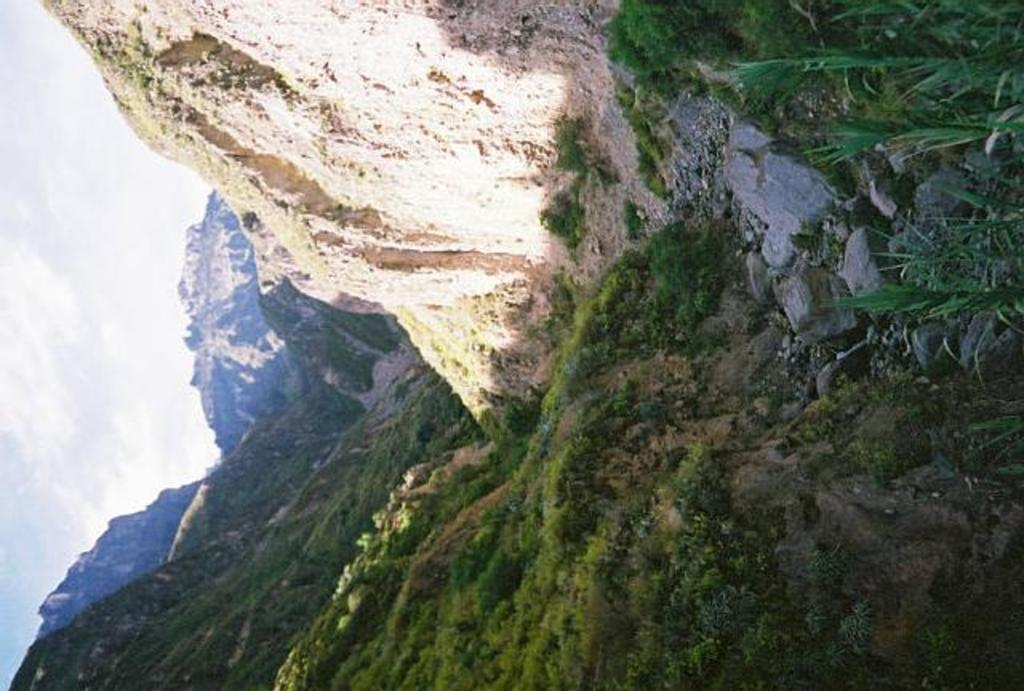What types of natural elements can be seen on the right side of the image? A: There are stones, grass, and plants on the right side of the image. What is located in the middle of the image? There are mountains and grass in the middle of the image. What is visible on the left side of the image? There are mountains on the left side of the image. How would you describe the sky in the image? The sky is cloudy. Reasoning: Let' Let's think step by step in order to produce the conversation. We start by identifying the main subjects and objects in the image based on the provided facts. We then formulate questions that focus on the location and characteristics of these subjects and objects, ensuring that each question can be answered definitively with the information given. We avoid yes/no questions and ensure that the language is simple and clear. Absurd Question/Answer: Can you see the thumb of the person who took the photo in the image? There is no thumb visible in the image, as it is a landscape photograph without any people present. What type of reward is being offered to the plants in the image? There is no reward being offered to the plants in the image; they are simply growing in their natural environment. 